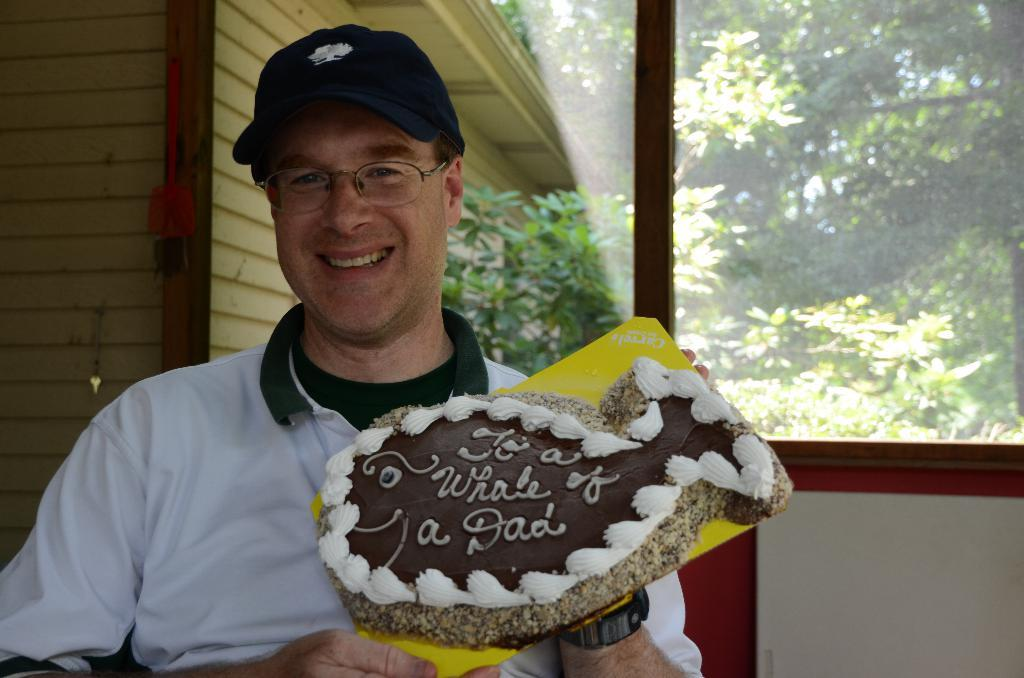What is the person in the image holding? The person is holding a cake in the image. What can be seen in the background of the image? There is a door, a house, trees, and the sky visible in the background of the image. What type of acoustics can be heard from the dinosaurs in the image? There are no dinosaurs present in the image, so it is not possible to determine the acoustics. 